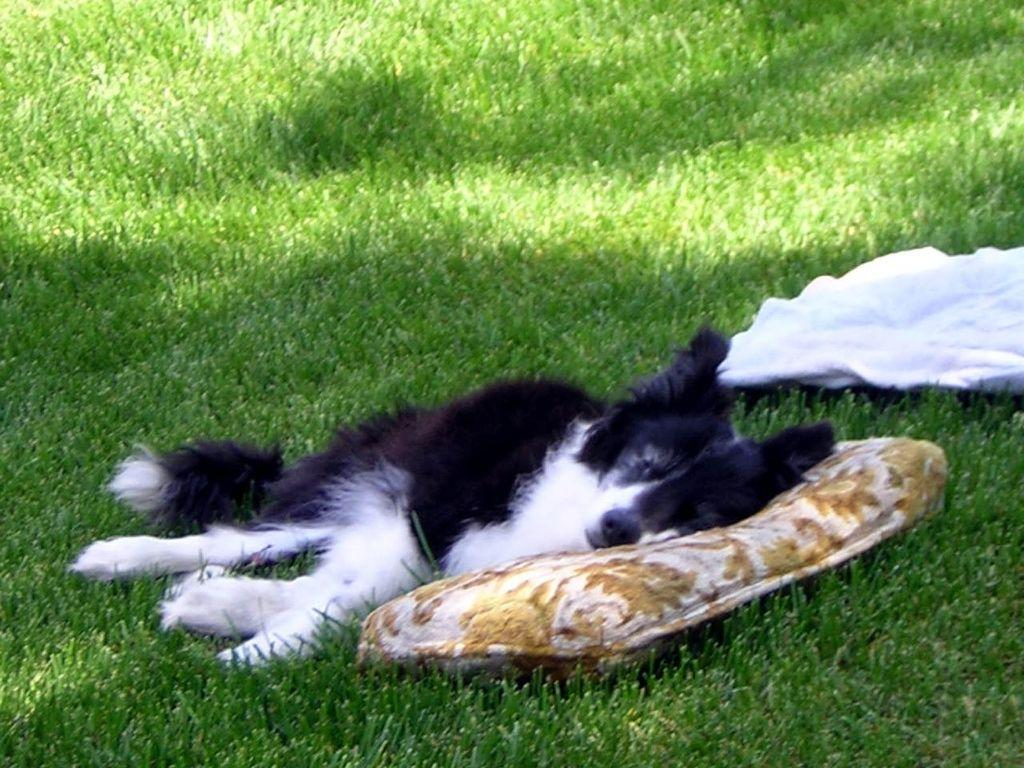What animal can be seen in the image? There is a dog in the image. What is the dog doing in the image? The dog is lying on the grass. What objects are placed on the grass in the image? There is a cushion and a cloth placed on the grass. How many ladybugs are crawling on the dog in the image? There are no ladybugs present in the image; it only features a dog, a cushion, and a cloth. 